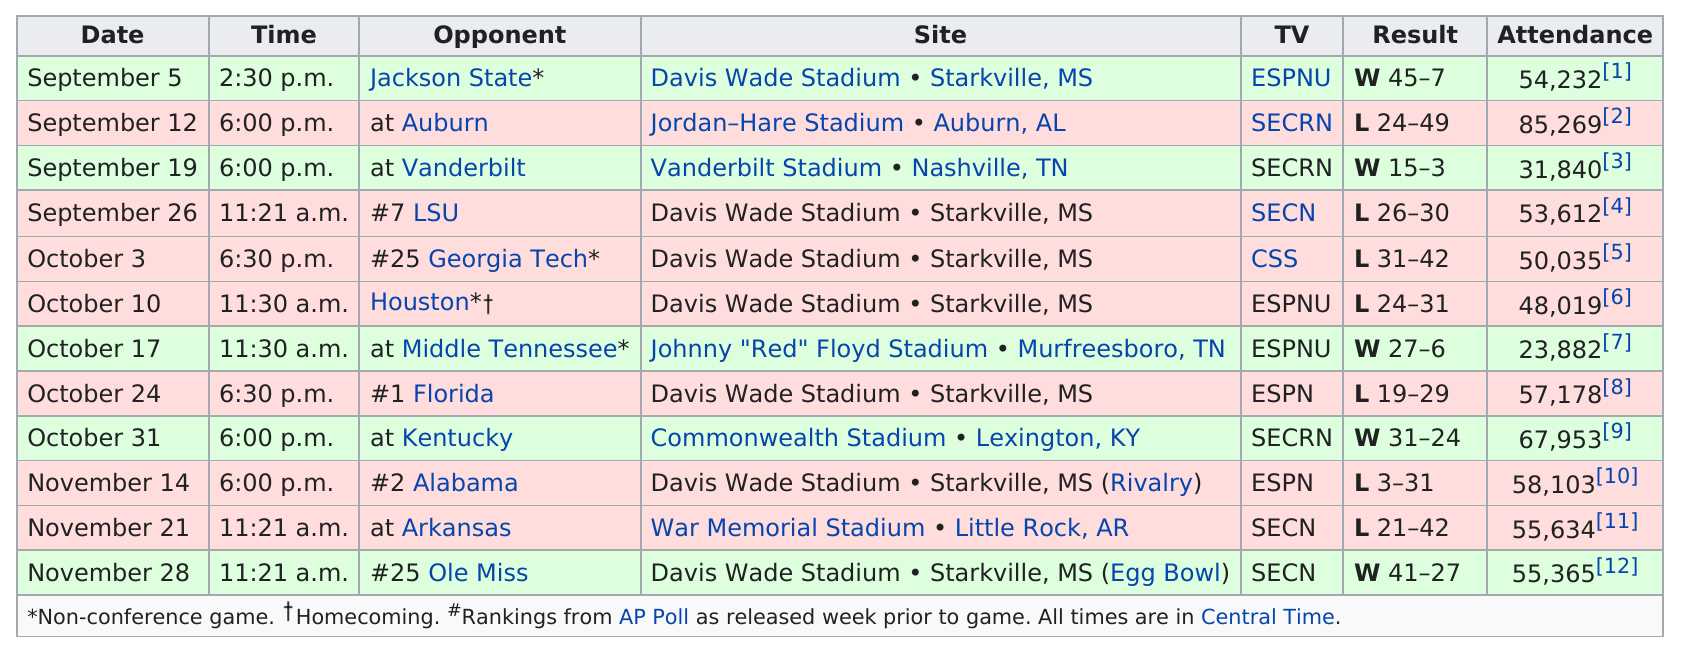List a handful of essential elements in this visual. On September 5th, there were 54,232 attendees at the game. After Jackson State, the opponent was Auburn. I, [insert name], am the last opponent to have faced Ole Miss. The team has won a total of 5 games. The Bulldogs won 5 games. 